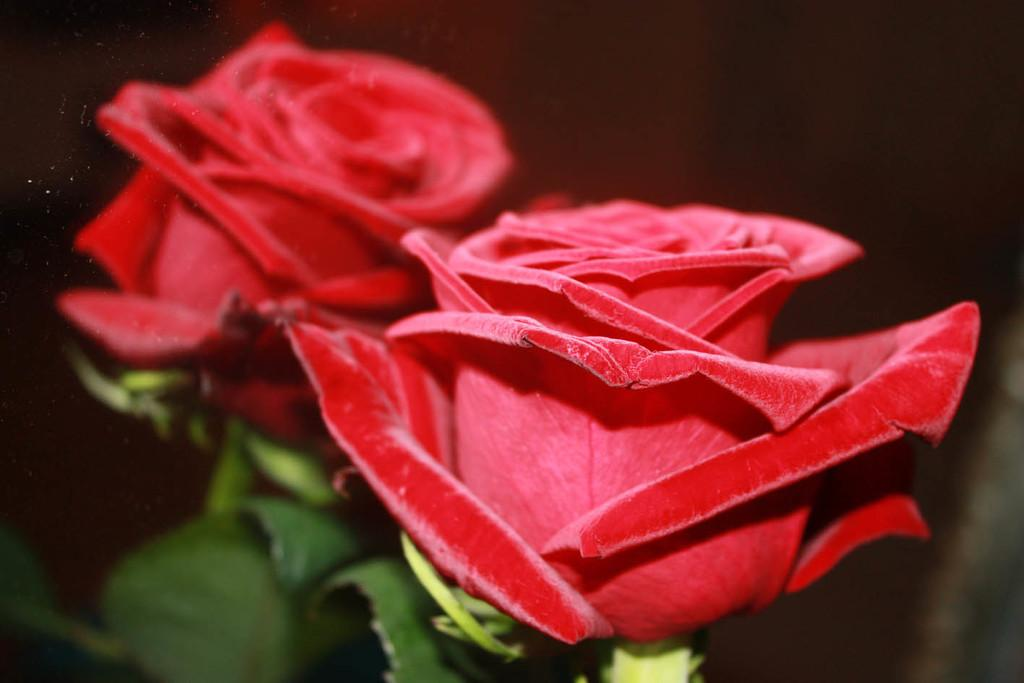What type of flowers can be seen in the image? There are two red flowers in the image. What color are the leaves in the image? The leaves in the image are green. What color is the background of the image? The background of the image is black. What is the weight of the cast in the image? There is no cast present in the image. 